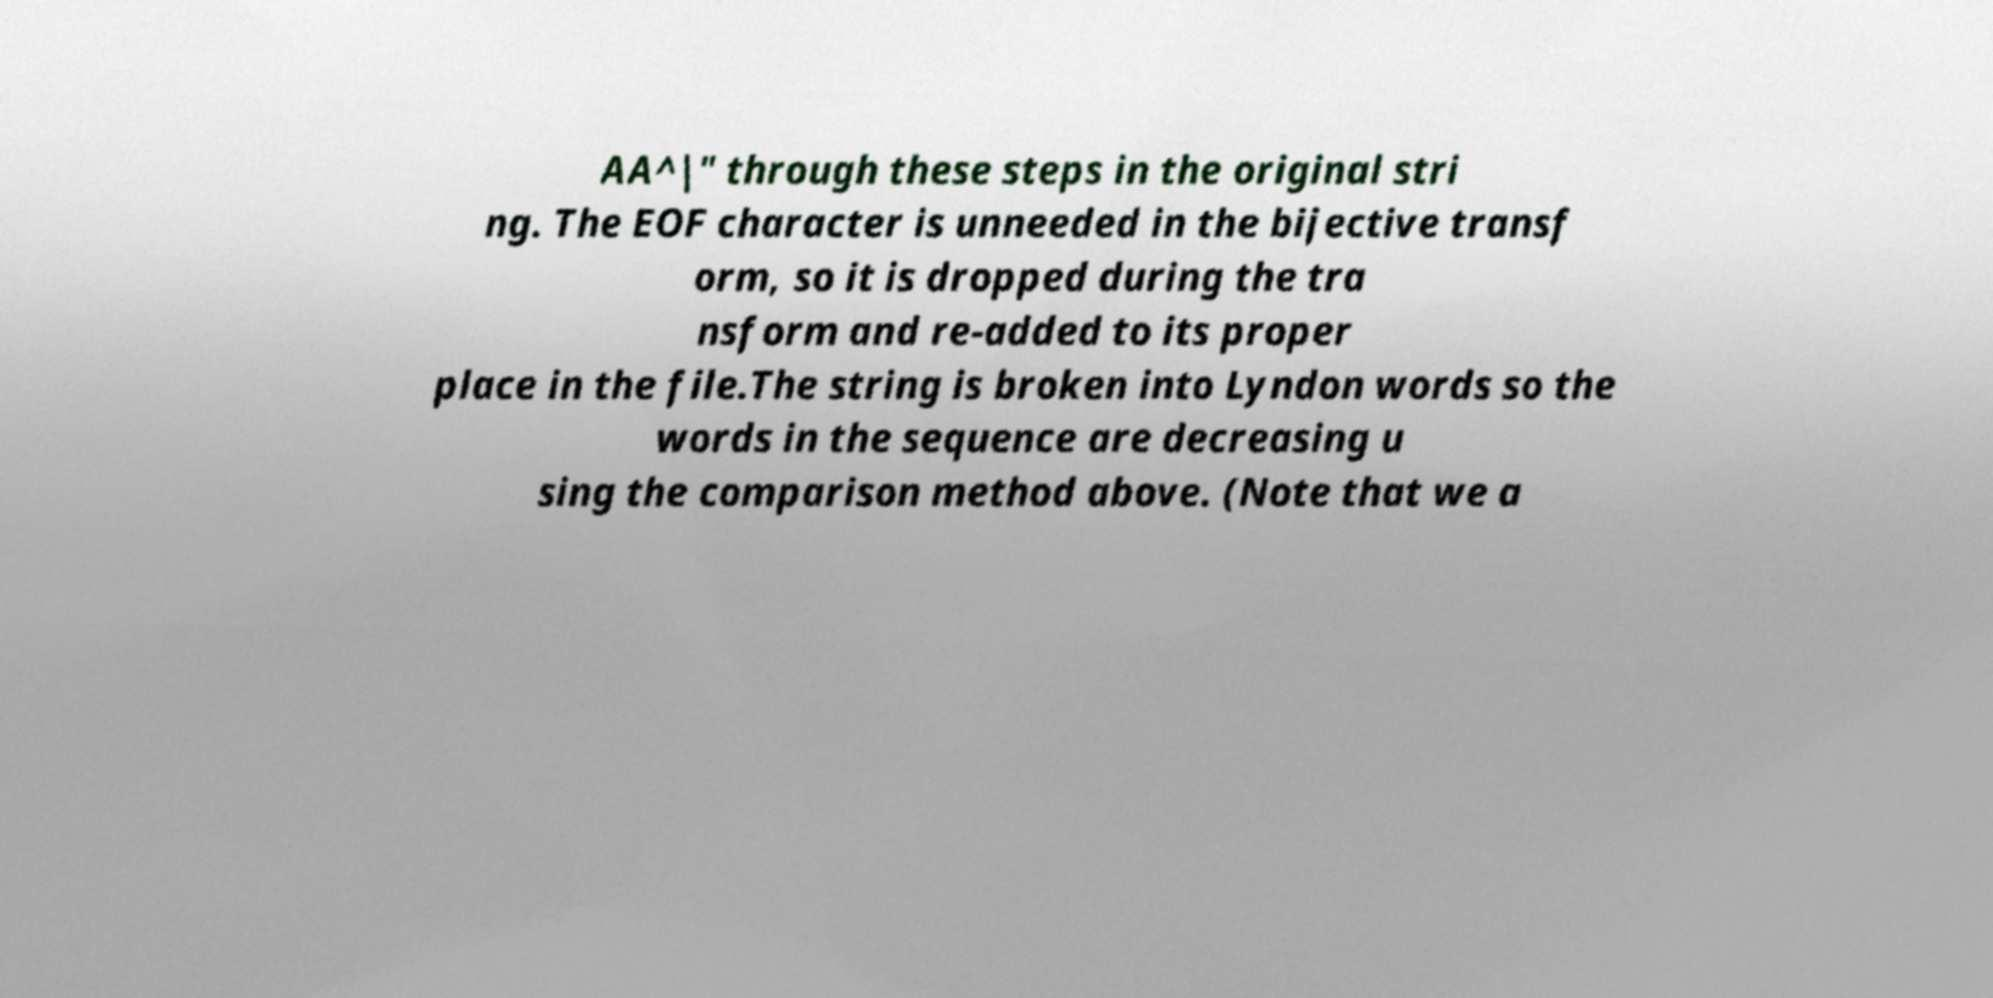Could you extract and type out the text from this image? AA^|" through these steps in the original stri ng. The EOF character is unneeded in the bijective transf orm, so it is dropped during the tra nsform and re-added to its proper place in the file.The string is broken into Lyndon words so the words in the sequence are decreasing u sing the comparison method above. (Note that we a 